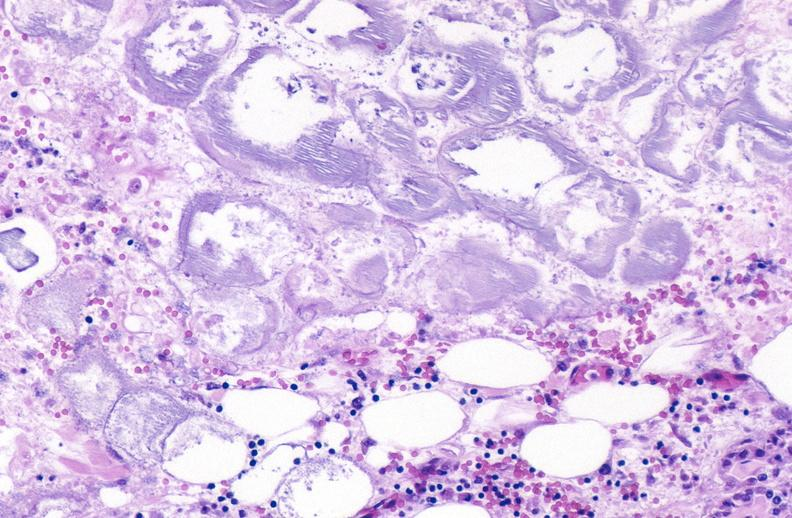where is this?
Answer the question using a single word or phrase. Pancreas 